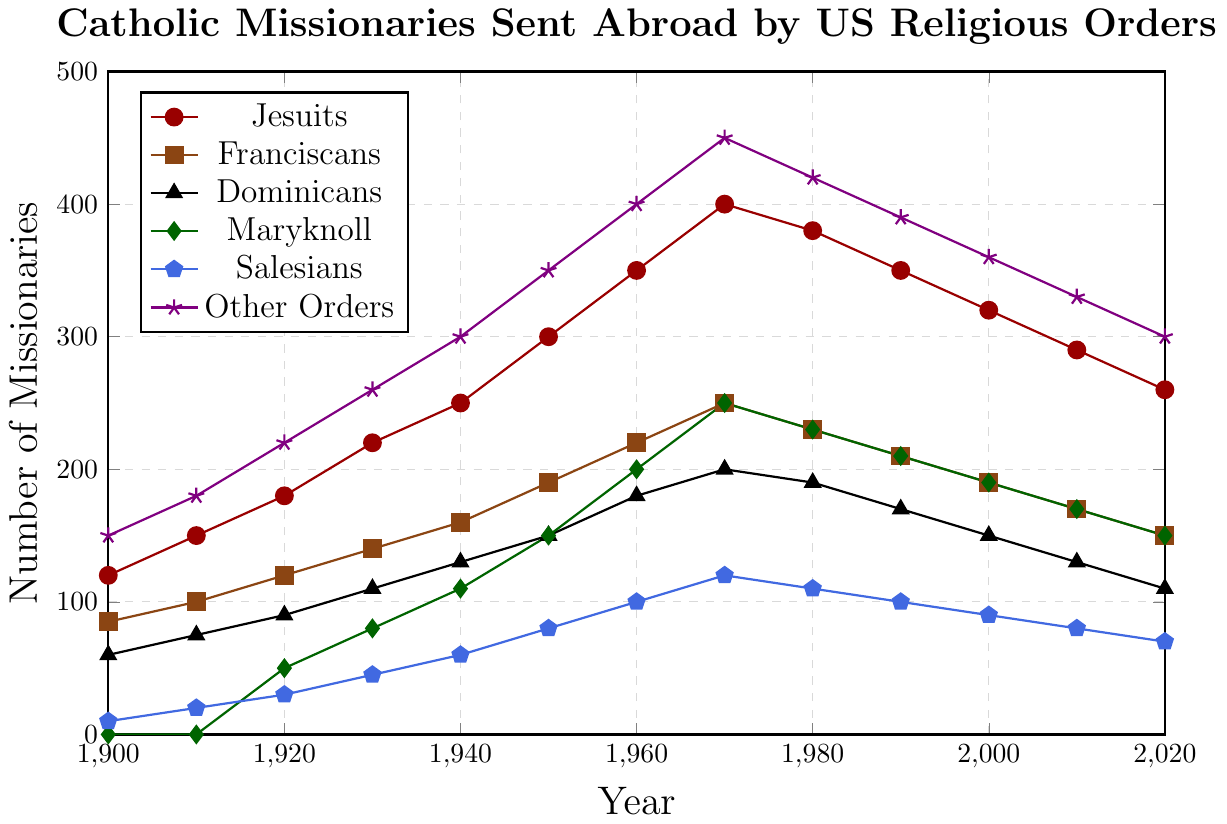How many Catholic missionaries were sent abroad by the US in total in 1950? Sum the number of missionaries sent abroad by each religious order in 1950: 300 (Jesuits) + 190 (Franciscans) + 150 (Dominicans) + 150 (Maryknoll) + 80 (Salesians) + 350 (Other Orders) = 1220.
Answer: 1220 Which religious order experienced a consistent decline in the number of missionaries sent abroad from 1970 to 2020? Checking the trends in the data for each religious order: Jesuits (decrease and fluctuate), Franciscans (decrease), Dominicans (decrease), Maryknoll (decrease after 1970), Salesians (decrease), and Other Orders (decrease). The Jesuits show consistent decline overall.
Answer: Jesuits In which year did the Maryknoll order send the most missionaries abroad? Check the data for each year: 1920 (50), 1930 (80), 1940 (110), 1950 (150), 1960 (200), 1970 (250), 1980 (230), 1990 (210), 2000 (190), 2010 (170), 2020 (150). The highest number is in 1970 (250).
Answer: 1970 What is the average number of missionaries sent by the Salesians across all years? Calculate the average: (10 + 20 + 30 + 45 + 60 + 80 + 100 + 120 + 110 + 100 + 90 + 80 + 70) / 13 = 73.85 (approx).
Answer: 73.85 Did the number of missionaries sent by the Dominicans ever exceed the number sent by the Franciscans? Compare the data points for both orders across all years. The Franciscans have consistently sent more missionaries than the Dominicans every year.
Answer: No How much did the number of missionaries sent by the Jesuits decrease from its peak in 1970 to 2020? The peak number for the Jesuits is in 1970 (400), and in 2020 it is (260). The decrease is 400 - 260 = 140.
Answer: 140 Which religious order had the highest initial number of missionaries sent abroad in 1900? From the data for 1900: Jesuits (120), Franciscans (85), Dominicans (60), Maryknoll (0), Salesians (10), Other Orders (150). Other Orders sent the highest initially (150).
Answer: Other Orders What is the difference in the number of missionaries sent by the Maryknoll order between 1940 and 1960? In 1940, Maryknoll sent 110 missionaries and in 1960, they sent 200. The difference is 200 - 110 = 90.
Answer: 90 Which religious order saw the largest increase in the number of missionaries from 1900 to 1970? Calculate the increase for each order over this period: Jesuits (400-120 = 280), Franciscans (250-85 = 165), Dominicans (200-60 = 140), Maryknoll (250-0 = 250), Salesians (120-10 = 110), Other Orders (450-150 = 300). The Jesuits had the largest increase (280).
Answer: Jesuits 